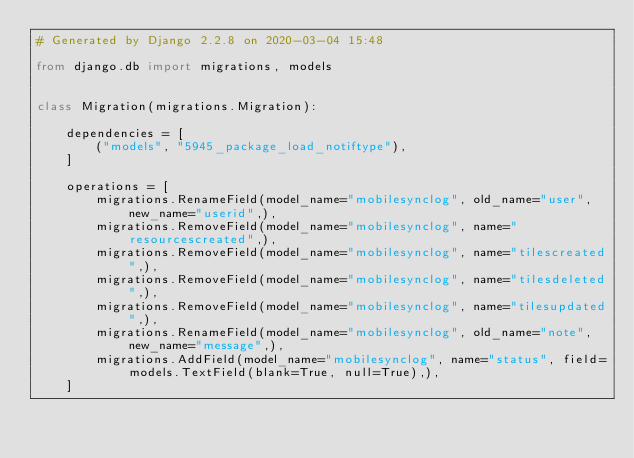<code> <loc_0><loc_0><loc_500><loc_500><_Python_># Generated by Django 2.2.8 on 2020-03-04 15:48

from django.db import migrations, models


class Migration(migrations.Migration):

    dependencies = [
        ("models", "5945_package_load_notiftype"),
    ]

    operations = [
        migrations.RenameField(model_name="mobilesynclog", old_name="user", new_name="userid",),
        migrations.RemoveField(model_name="mobilesynclog", name="resourcescreated",),
        migrations.RemoveField(model_name="mobilesynclog", name="tilescreated",),
        migrations.RemoveField(model_name="mobilesynclog", name="tilesdeleted",),
        migrations.RemoveField(model_name="mobilesynclog", name="tilesupdated",),
        migrations.RenameField(model_name="mobilesynclog", old_name="note", new_name="message",),
        migrations.AddField(model_name="mobilesynclog", name="status", field=models.TextField(blank=True, null=True),),
    ]
</code> 